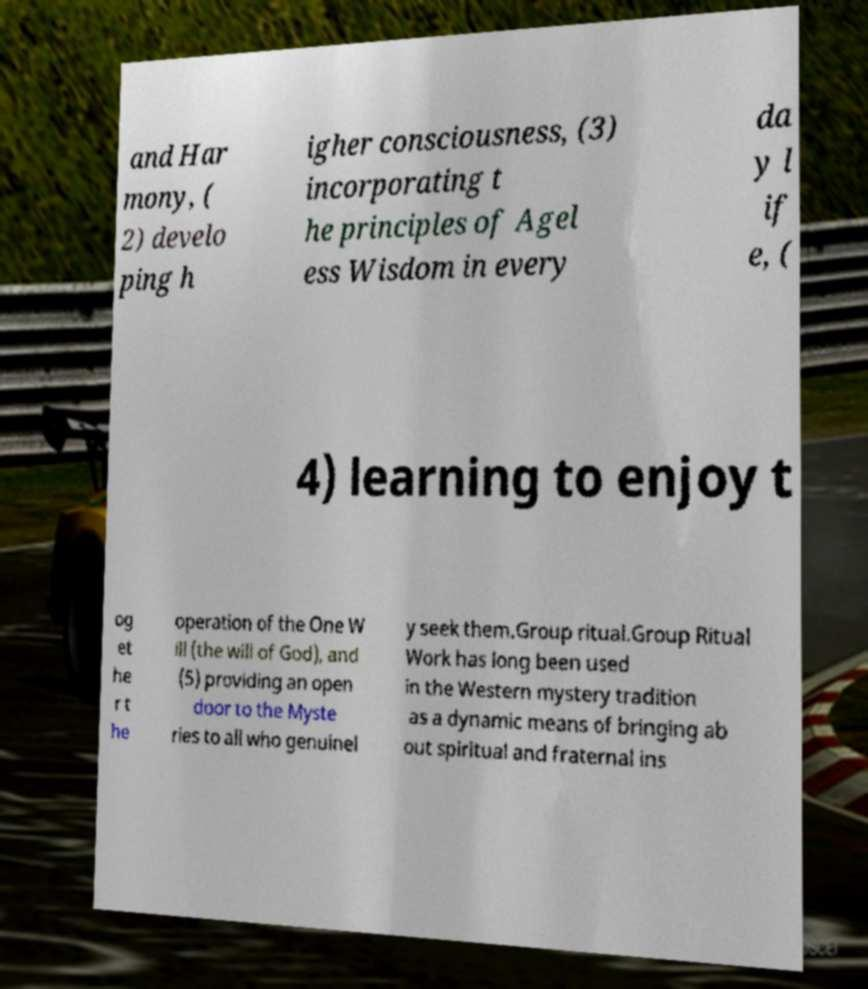Please identify and transcribe the text found in this image. and Har mony, ( 2) develo ping h igher consciousness, (3) incorporating t he principles of Agel ess Wisdom in every da y l if e, ( 4) learning to enjoy t og et he r t he operation of the One W ill (the will of God), and (5) providing an open door to the Myste ries to all who genuinel y seek them.Group ritual.Group Ritual Work has long been used in the Western mystery tradition as a dynamic means of bringing ab out spiritual and fraternal ins 